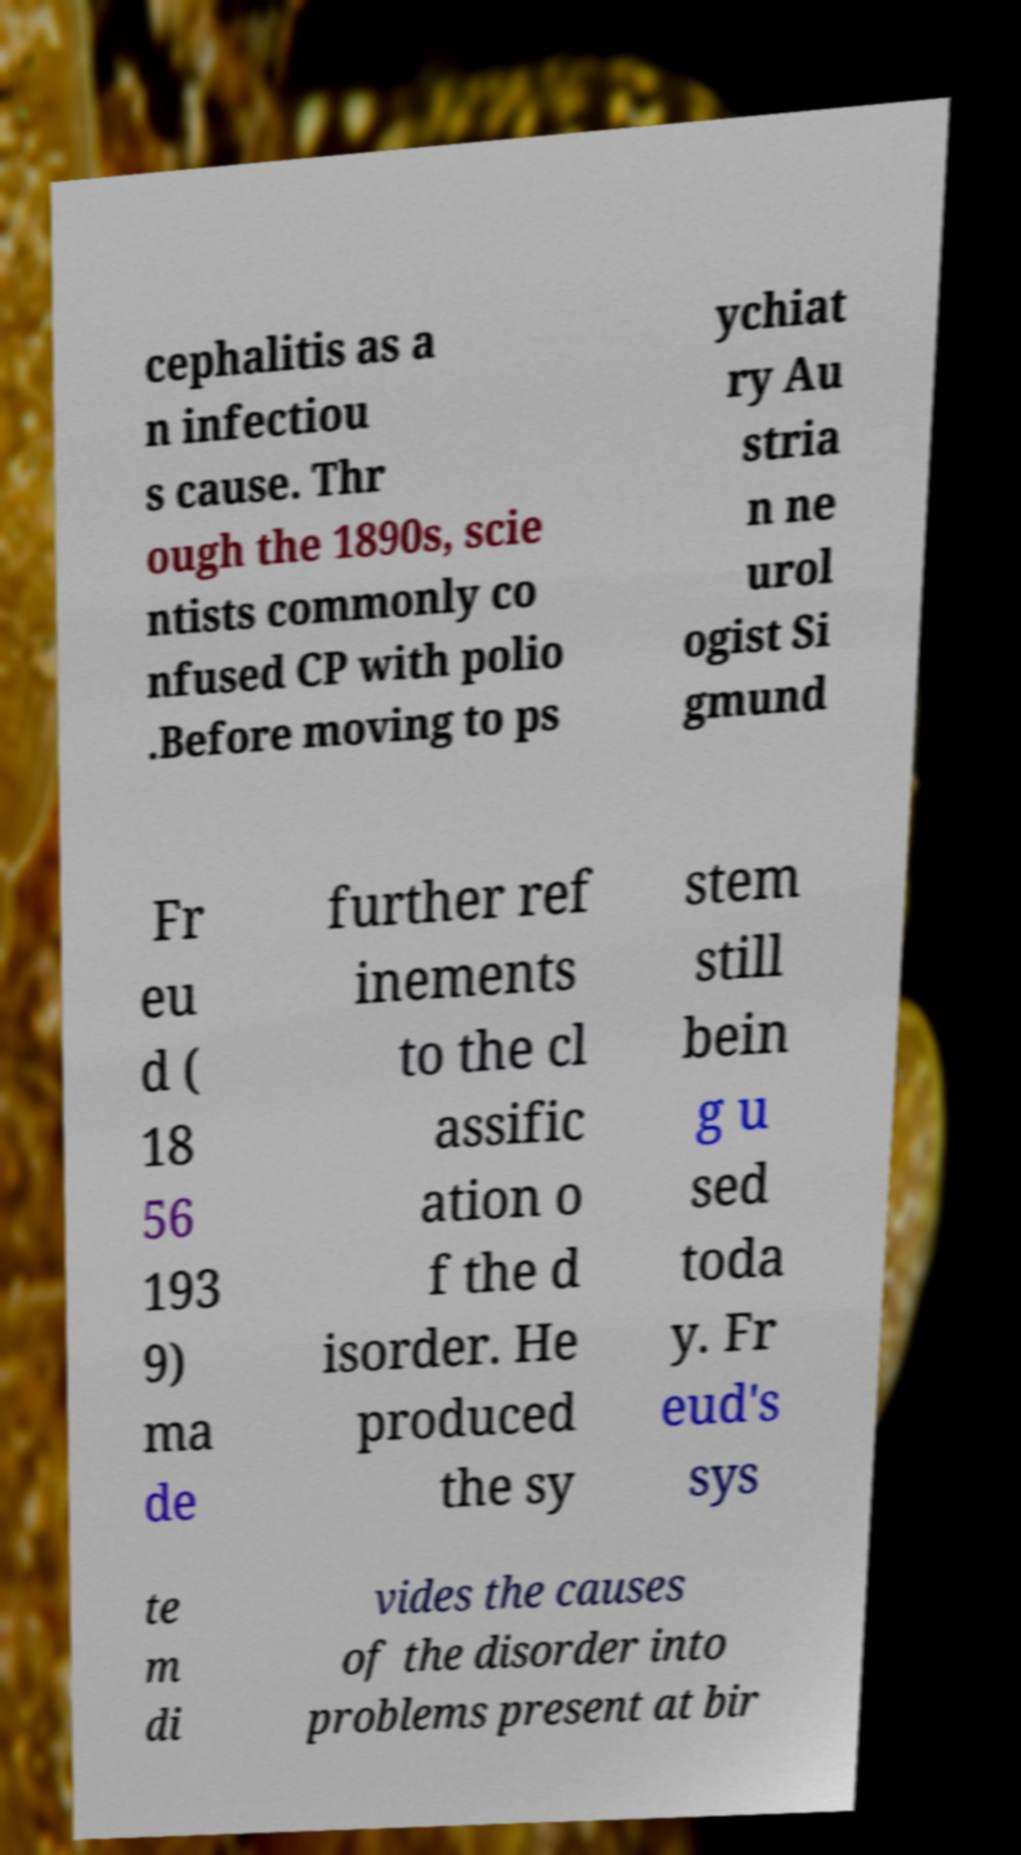There's text embedded in this image that I need extracted. Can you transcribe it verbatim? cephalitis as a n infectiou s cause. Thr ough the 1890s, scie ntists commonly co nfused CP with polio .Before moving to ps ychiat ry Au stria n ne urol ogist Si gmund Fr eu d ( 18 56 193 9) ma de further ref inements to the cl assific ation o f the d isorder. He produced the sy stem still bein g u sed toda y. Fr eud's sys te m di vides the causes of the disorder into problems present at bir 